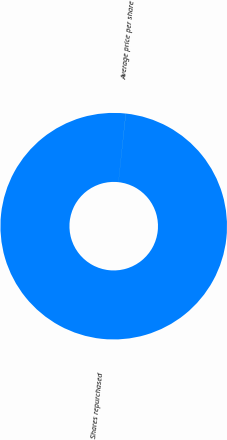Convert chart to OTSL. <chart><loc_0><loc_0><loc_500><loc_500><pie_chart><fcel>Shares repurchased<fcel>Average price per share<nl><fcel>99.99%<fcel>0.01%<nl></chart> 